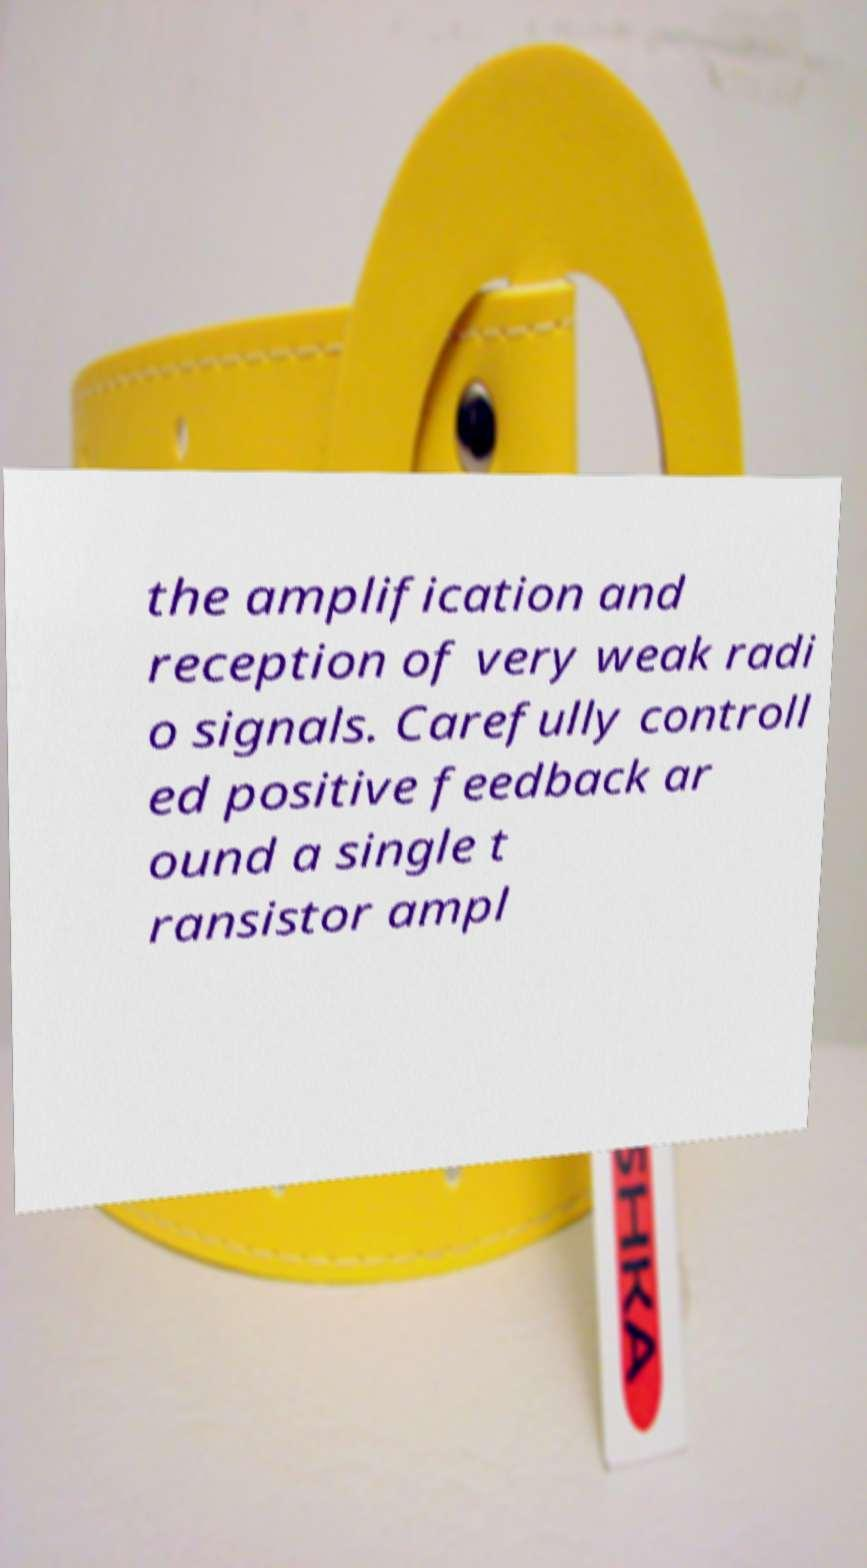There's text embedded in this image that I need extracted. Can you transcribe it verbatim? the amplification and reception of very weak radi o signals. Carefully controll ed positive feedback ar ound a single t ransistor ampl 